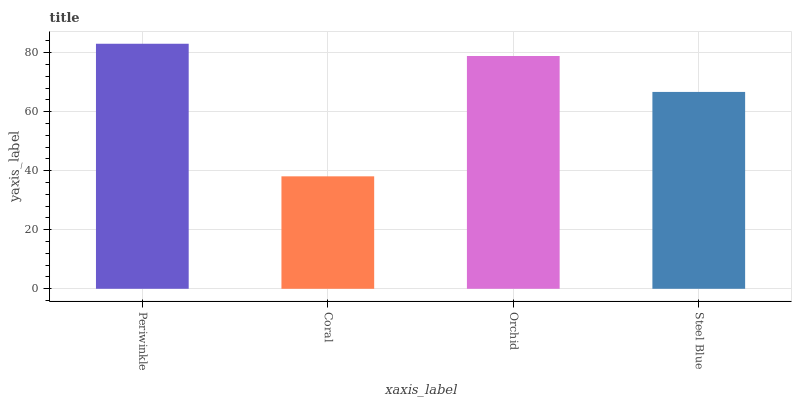Is Coral the minimum?
Answer yes or no. Yes. Is Periwinkle the maximum?
Answer yes or no. Yes. Is Orchid the minimum?
Answer yes or no. No. Is Orchid the maximum?
Answer yes or no. No. Is Orchid greater than Coral?
Answer yes or no. Yes. Is Coral less than Orchid?
Answer yes or no. Yes. Is Coral greater than Orchid?
Answer yes or no. No. Is Orchid less than Coral?
Answer yes or no. No. Is Orchid the high median?
Answer yes or no. Yes. Is Steel Blue the low median?
Answer yes or no. Yes. Is Steel Blue the high median?
Answer yes or no. No. Is Orchid the low median?
Answer yes or no. No. 